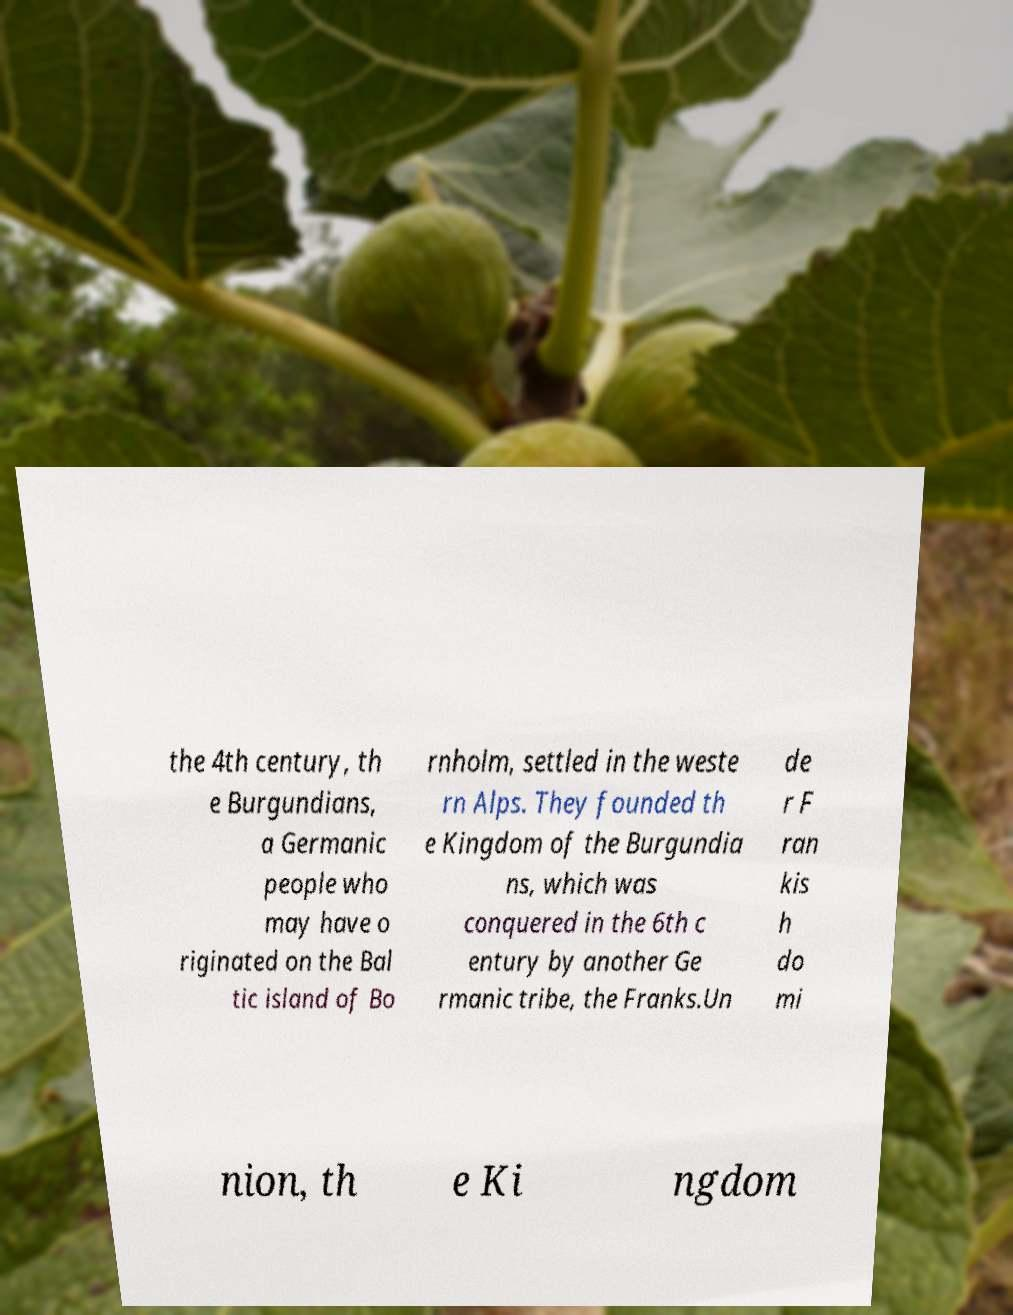I need the written content from this picture converted into text. Can you do that? the 4th century, th e Burgundians, a Germanic people who may have o riginated on the Bal tic island of Bo rnholm, settled in the weste rn Alps. They founded th e Kingdom of the Burgundia ns, which was conquered in the 6th c entury by another Ge rmanic tribe, the Franks.Un de r F ran kis h do mi nion, th e Ki ngdom 